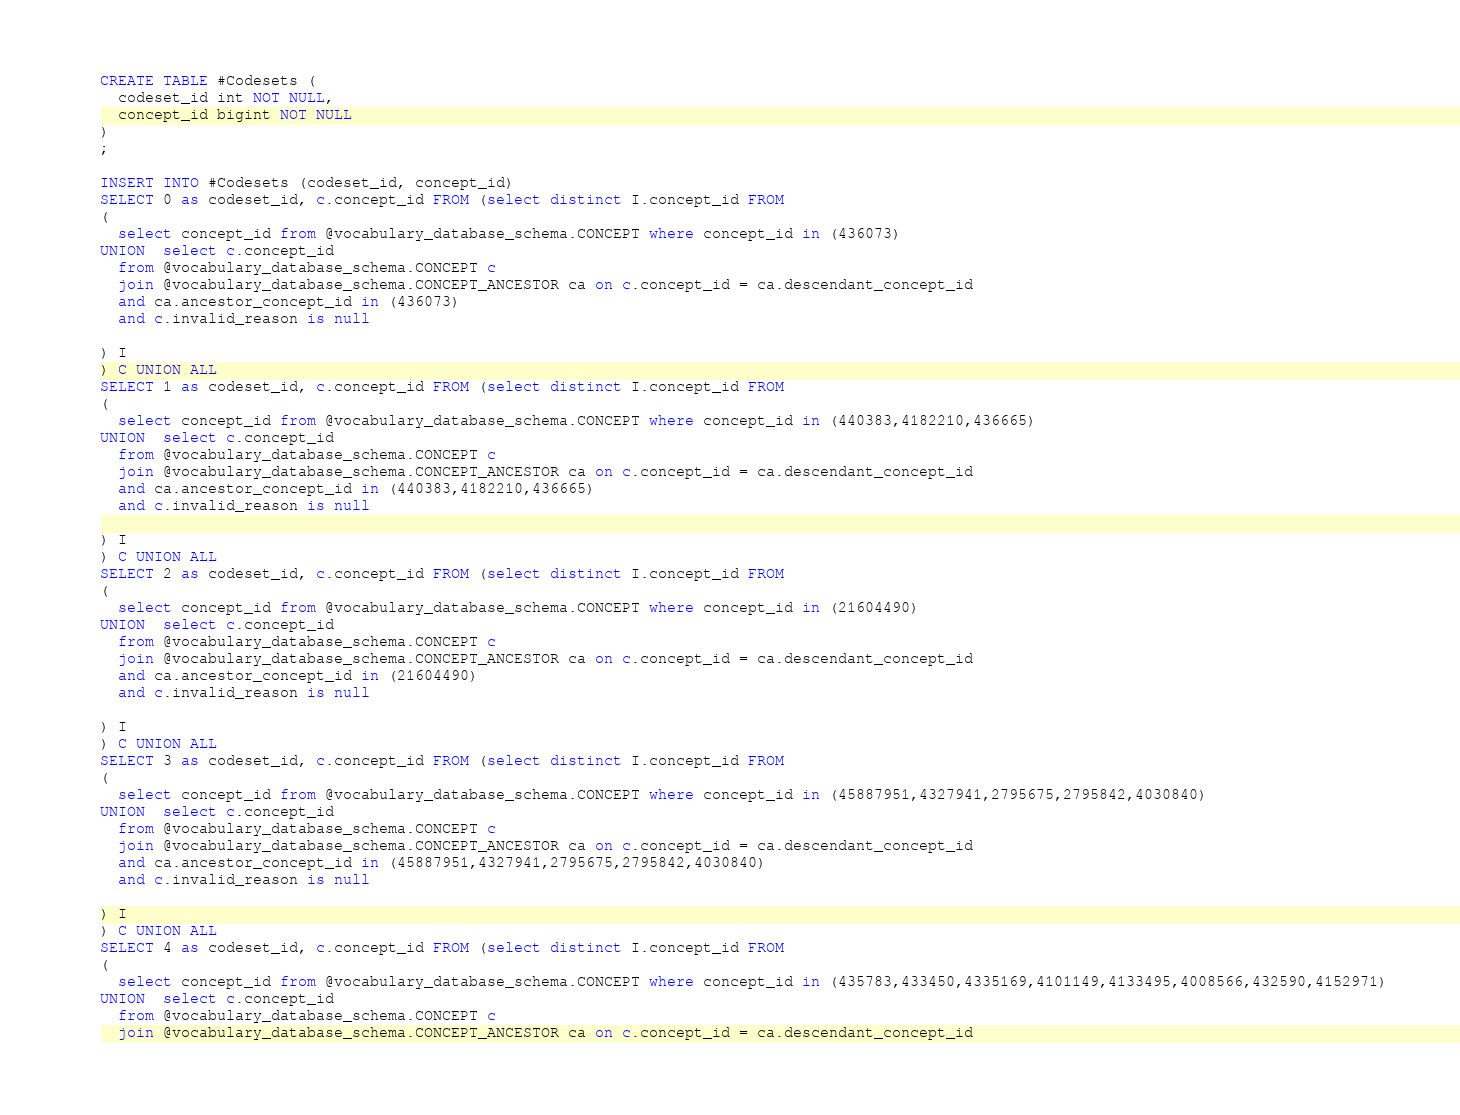Convert code to text. <code><loc_0><loc_0><loc_500><loc_500><_SQL_>CREATE TABLE #Codesets (
  codeset_id int NOT NULL,
  concept_id bigint NOT NULL
)
;

INSERT INTO #Codesets (codeset_id, concept_id)
SELECT 0 as codeset_id, c.concept_id FROM (select distinct I.concept_id FROM
(
  select concept_id from @vocabulary_database_schema.CONCEPT where concept_id in (436073)
UNION  select c.concept_id
  from @vocabulary_database_schema.CONCEPT c
  join @vocabulary_database_schema.CONCEPT_ANCESTOR ca on c.concept_id = ca.descendant_concept_id
  and ca.ancestor_concept_id in (436073)
  and c.invalid_reason is null

) I
) C UNION ALL
SELECT 1 as codeset_id, c.concept_id FROM (select distinct I.concept_id FROM
(
  select concept_id from @vocabulary_database_schema.CONCEPT where concept_id in (440383,4182210,436665)
UNION  select c.concept_id
  from @vocabulary_database_schema.CONCEPT c
  join @vocabulary_database_schema.CONCEPT_ANCESTOR ca on c.concept_id = ca.descendant_concept_id
  and ca.ancestor_concept_id in (440383,4182210,436665)
  and c.invalid_reason is null

) I
) C UNION ALL
SELECT 2 as codeset_id, c.concept_id FROM (select distinct I.concept_id FROM
(
  select concept_id from @vocabulary_database_schema.CONCEPT where concept_id in (21604490)
UNION  select c.concept_id
  from @vocabulary_database_schema.CONCEPT c
  join @vocabulary_database_schema.CONCEPT_ANCESTOR ca on c.concept_id = ca.descendant_concept_id
  and ca.ancestor_concept_id in (21604490)
  and c.invalid_reason is null

) I
) C UNION ALL
SELECT 3 as codeset_id, c.concept_id FROM (select distinct I.concept_id FROM
(
  select concept_id from @vocabulary_database_schema.CONCEPT where concept_id in (45887951,4327941,2795675,2795842,4030840)
UNION  select c.concept_id
  from @vocabulary_database_schema.CONCEPT c
  join @vocabulary_database_schema.CONCEPT_ANCESTOR ca on c.concept_id = ca.descendant_concept_id
  and ca.ancestor_concept_id in (45887951,4327941,2795675,2795842,4030840)
  and c.invalid_reason is null

) I
) C UNION ALL
SELECT 4 as codeset_id, c.concept_id FROM (select distinct I.concept_id FROM
(
  select concept_id from @vocabulary_database_schema.CONCEPT where concept_id in (435783,433450,4335169,4101149,4133495,4008566,432590,4152971)
UNION  select c.concept_id
  from @vocabulary_database_schema.CONCEPT c
  join @vocabulary_database_schema.CONCEPT_ANCESTOR ca on c.concept_id = ca.descendant_concept_id</code> 